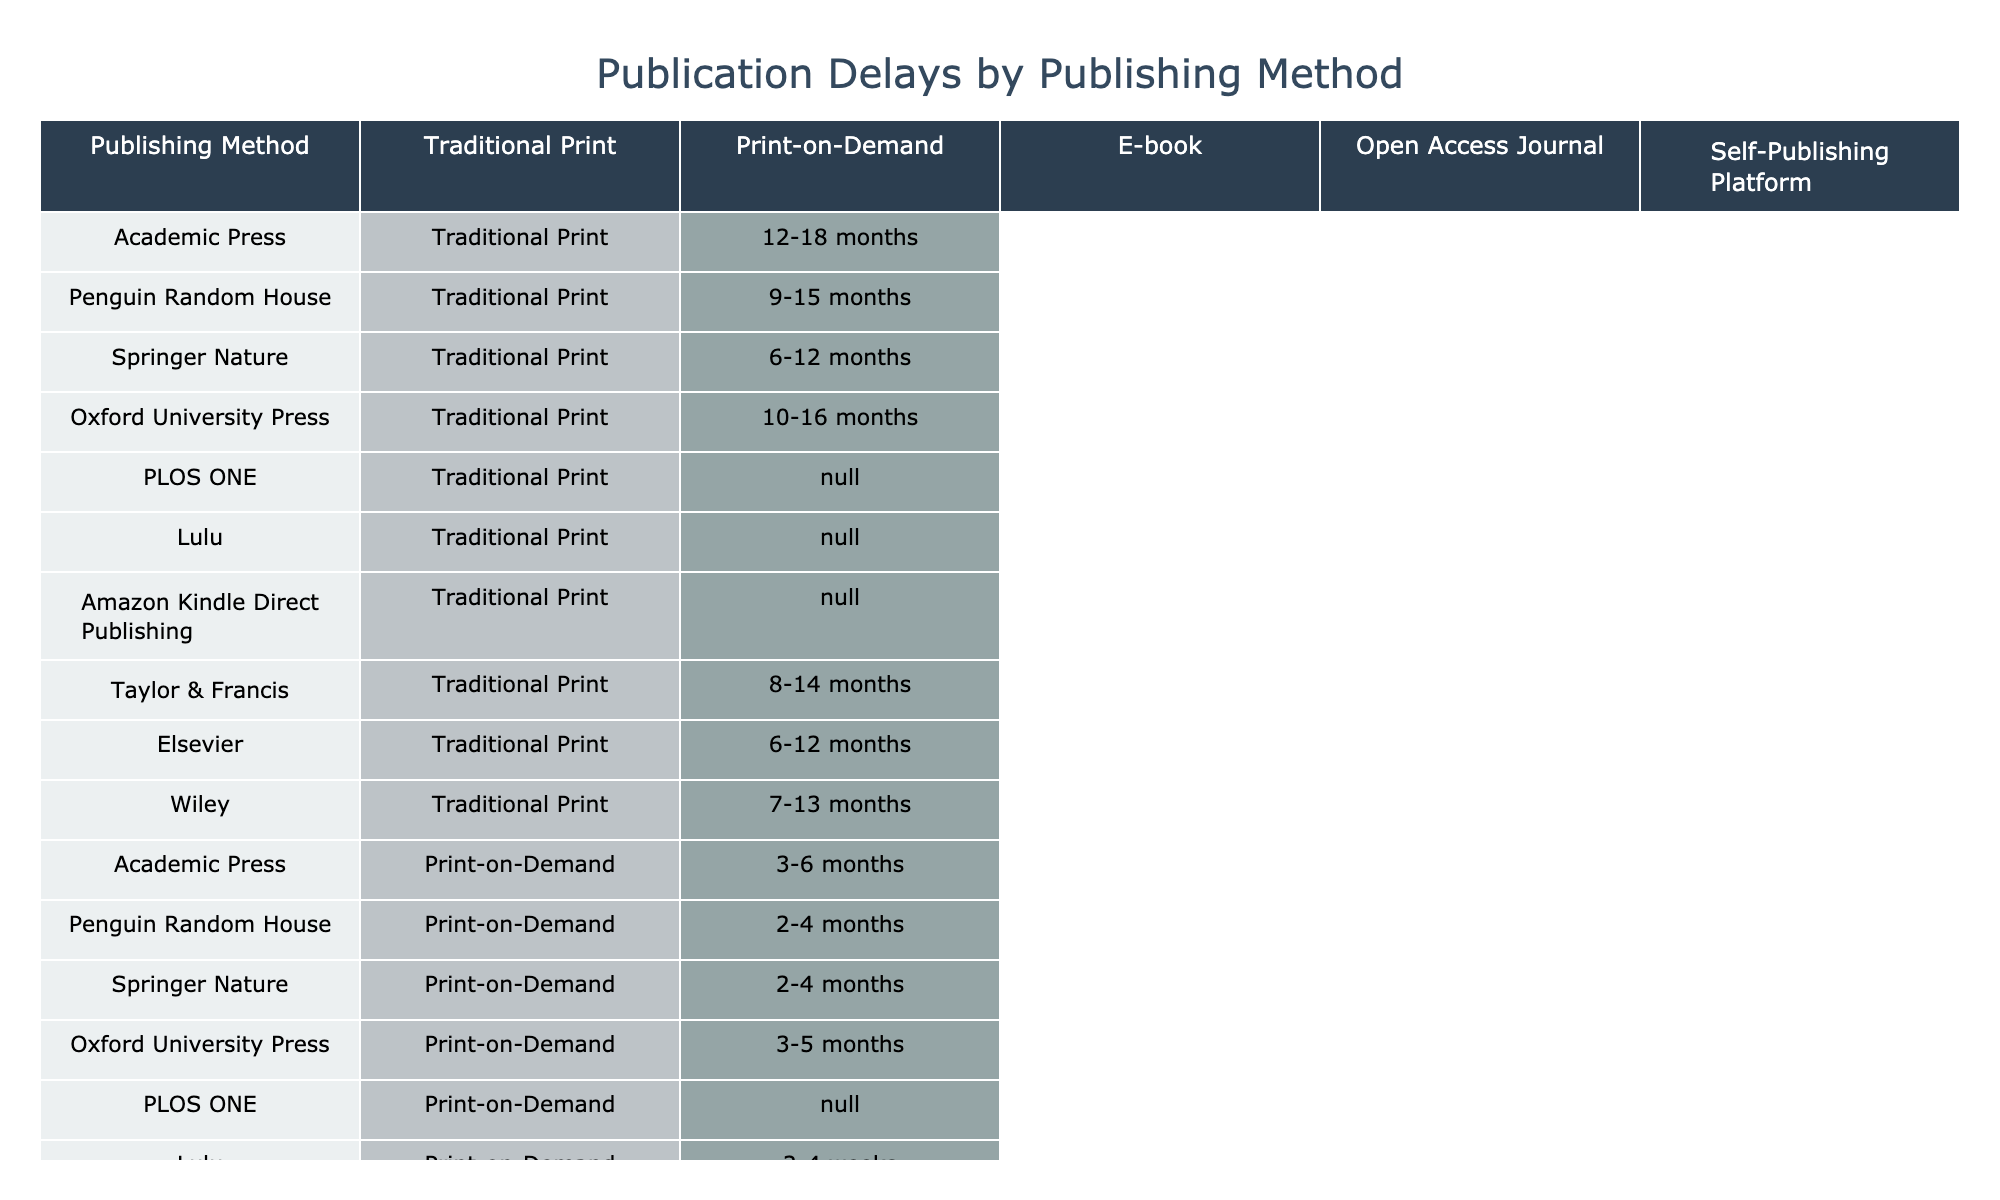What is the longest publication delay for traditional print publishing? The longest publication delay for traditional print publishing is found by scanning the values in that column. The maximum value is 18 months from Academic Press and Oxford University Press, which both have this delay.
Answer: 18 months Which publishing method is the quickest for e-books? The quickest publication delay for e-books is from Amazon Kindle Direct Publishing, which has a delay of 24 to 72 hours.
Answer: 24-72 hours How many publishing methods have a submission-to-publication delay of less than one month for self-publishing platforms? The self-publishing platform has delays of 1-7 days, which is less than one month. Therefore, there is one method listed specifically under self-publishing, which is Lulu.
Answer: 1 Is there a publisher that uses Print-on-Demand with no identified publication delay? By looking through the Print-on-Demand column for all publishers, Lulu is the only publisher listed that has identified delays but does not specify any for Academic Press or PLOS ONE in their respective methods, meaning others do have defined delays.
Answer: No For academic press publishing, which method has the shortest publication delay? To determine the shortest delay for academic press publishing, we review the column and see that PLOS ONE is absent from traditional publishing methods; however, Springer Nature offers a delay of 6-12 months, which is the shortest within traditional academic press.
Answer: 6 months What is the average delay for Open Access Journal publishing methods? To calculate the average, list the available delays for Open Access Journals: 4-8 weeks (from Academic Press), 3-6 weeks (from Springer Nature), 6-10 weeks (from Oxford University Press), 2-3 months (from PLOS ONE), and 4-8 weeks (from Taylor & Francis). Converting them into days gives us an average delay around 5 weeks.
Answer: Approximately 5 weeks Which publishing method generally has the least variability in its delay times? By analyzing the ranges in each column, Amazon Kindle Direct Publishing and Lulu have the tightest range for e-books and self-publishing, respectively, indicating less variability.
Answer: Amazon Kindle Direct Publishing How does the delay for Penguin Random House compare to that of Taylor & Francis for traditional print publishing? Penguin Random House has delays of 9-15 months while Taylor & Francis shows delays of 8-14 months. The range is slightly lower (by one month) for Taylor & Francis.
Answer: Taylor & Francis has a shorter range What is the difference in maximum and minimum delays for academic press publishing methods? Minimum delay in academic press is 6 months (from Springer Nature) and maximum is 18 months (from Academic Press). The difference is calculated by subtracting the minimum from the maximum: 18 - 6 = 12 months.
Answer: 12 months 